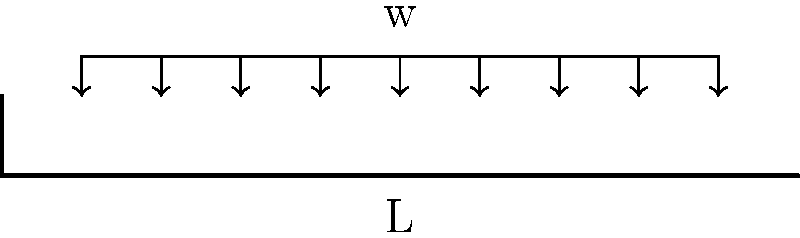In un contesto letterario, immagina di analizzare la struttura di un romanzo come se fosse una trave a sbalzo sottoposta a un carico distribuito uniformemente. Considerando che la lunghezza della trave rappresenta la progressione della trama e il carico distribuito simboleggia l'intensità emotiva costante lungo la narrazione, come si comporterebbero il taglio e il momento flettente in questo "romanzo-trave"? Descrivi qualitativamente l'andamento dei diagrammi di taglio e momento flettente. Per rispondere a questa domanda, analizziamo il comportamento di una trave a sbalzo con carico distribuito uniformemente, correlando ogni aspetto alla struttura di un romanzo:

1. Trave a sbalzo: Rappresenta la struttura del romanzo, fissa all'inizio (introduzione) e libera alla fine (conclusione).

2. Carico distribuito uniformemente: Simboleggia l'intensità emotiva costante lungo la narrazione.

3. Diagramma del taglio:
   - All'estremità fissa (x = 0), il taglio è massimo e positivo: $$V_{max} = wL$$
   - Decresce linearmente fino a zero all'estremità libera (x = L)
   - Equazione: $$V(x) = w(L-x)$$
   - Interpretazione: La tensione narrativa è massima all'inizio e diminuisce gradualmente verso la conclusione.

4. Diagramma del momento flettente:
   - All'estremità fissa (x = 0), il momento è massimo: $$M_{max} = \frac{wL^2}{2}$$
   - Decresce parabolicamente fino a zero all'estremità libera (x = L)
   - Equazione: $$M(x) = \frac{w}{2}(L-x)^2$$
   - Interpretazione: La complessità e la profondità della trama sono massime all'inizio e si risolvono gradualmente verso la conclusione.

5. Relazione tra taglio e momento:
   - Il taglio è la derivata del momento rispetto a x: $$V(x) = \frac{dM(x)}{dx}$$
   - Interpretazione: I cambiamenti nella tensione narrativa influenzano direttamente la complessità della trama.

Questa analogia meccanica ci permette di visualizzare come la struttura di un romanzo possa essere analizzata in termini di distribuzione della tensione narrativa e complessità della trama lungo l'arco della storia.
Answer: Il taglio decresce linearmente dall'inizio alla fine, mentre il momento flettente decresce parabolicamente, riflettendo rispettivamente la diminuzione della tensione narrativa e la risoluzione graduale della complessità della trama. 